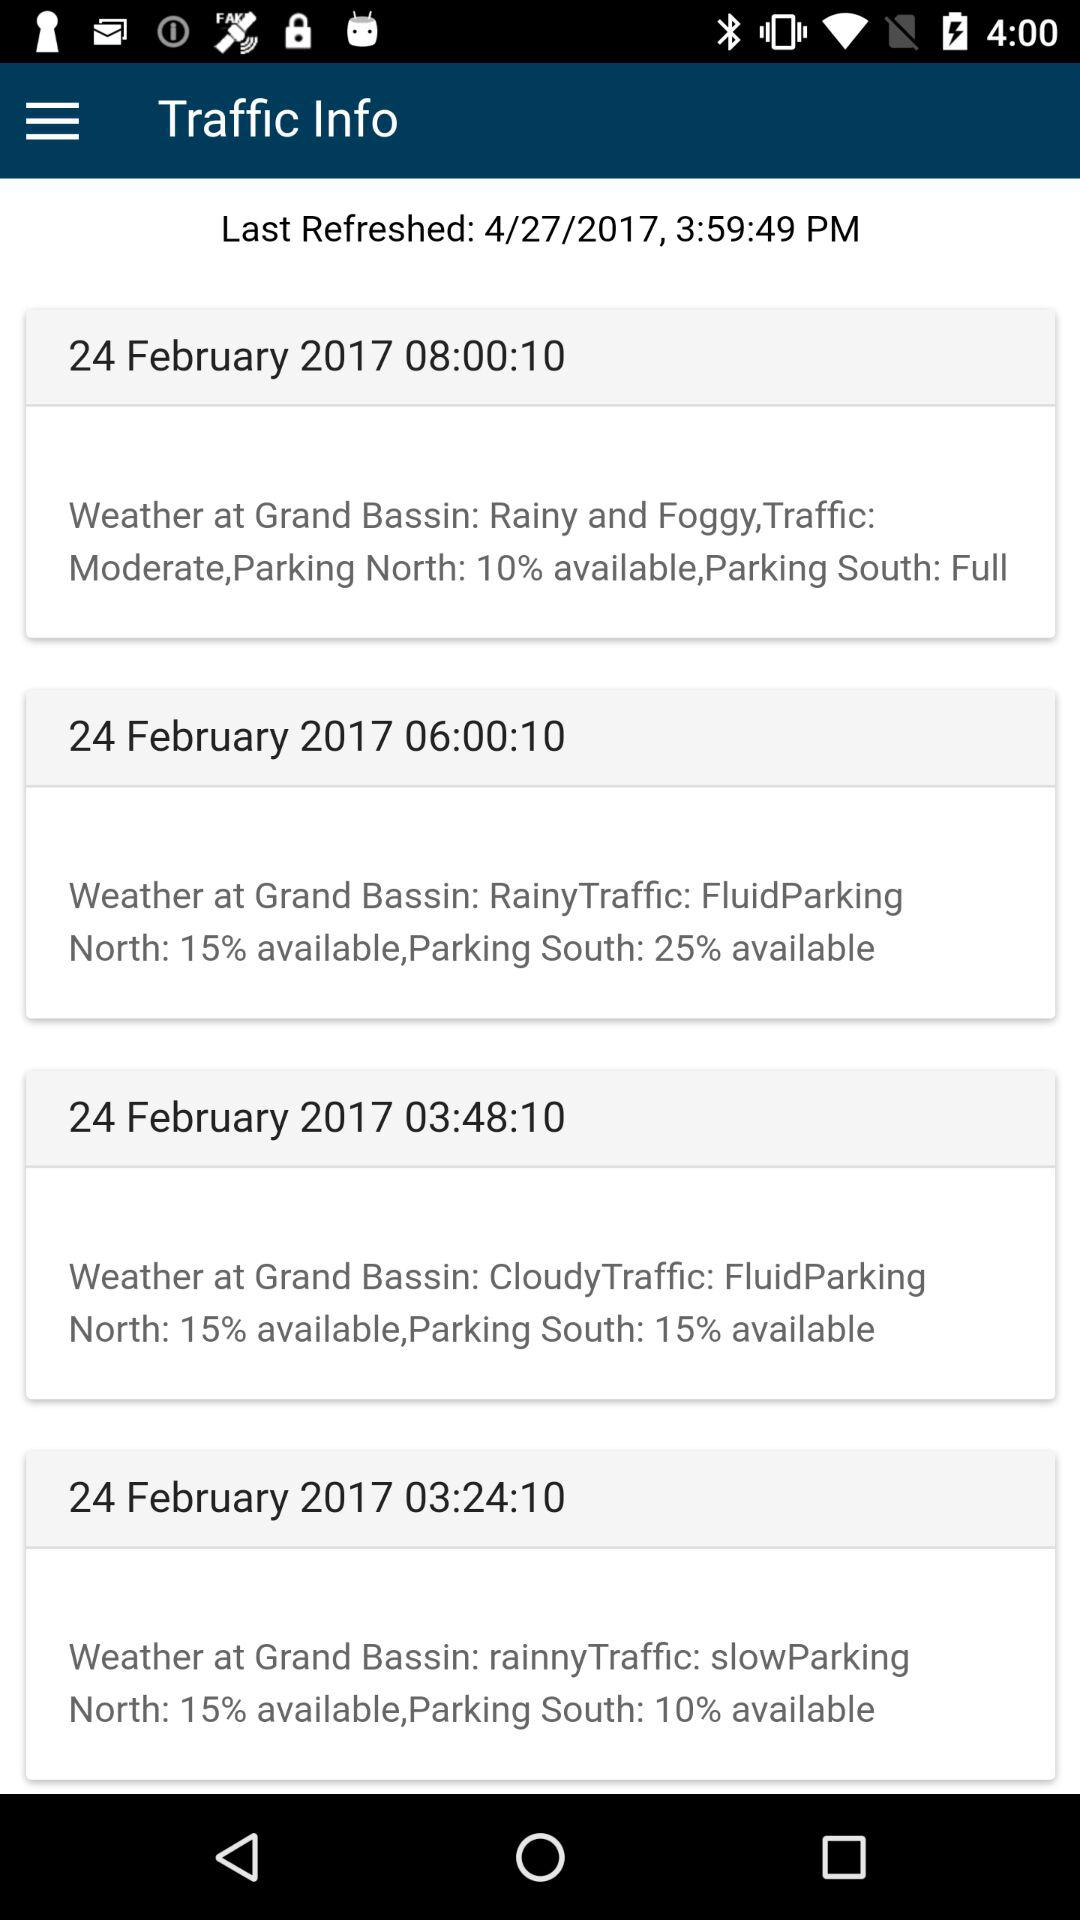At what time was the north parking 10% available? The north parking was 10% available at 08:00:10. 